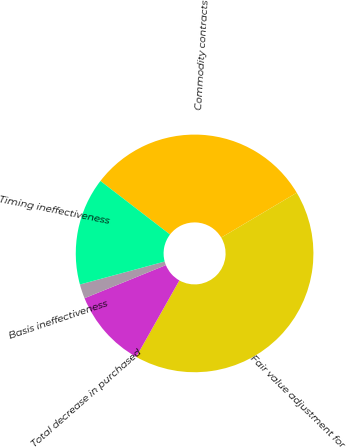Convert chart to OTSL. <chart><loc_0><loc_0><loc_500><loc_500><pie_chart><fcel>Commodity contracts<fcel>Fair value adjustment for<fcel>Total decrease in purchased<fcel>Basis ineffectiveness<fcel>Timing ineffectiveness<nl><fcel>31.03%<fcel>41.71%<fcel>10.67%<fcel>1.94%<fcel>14.65%<nl></chart> 